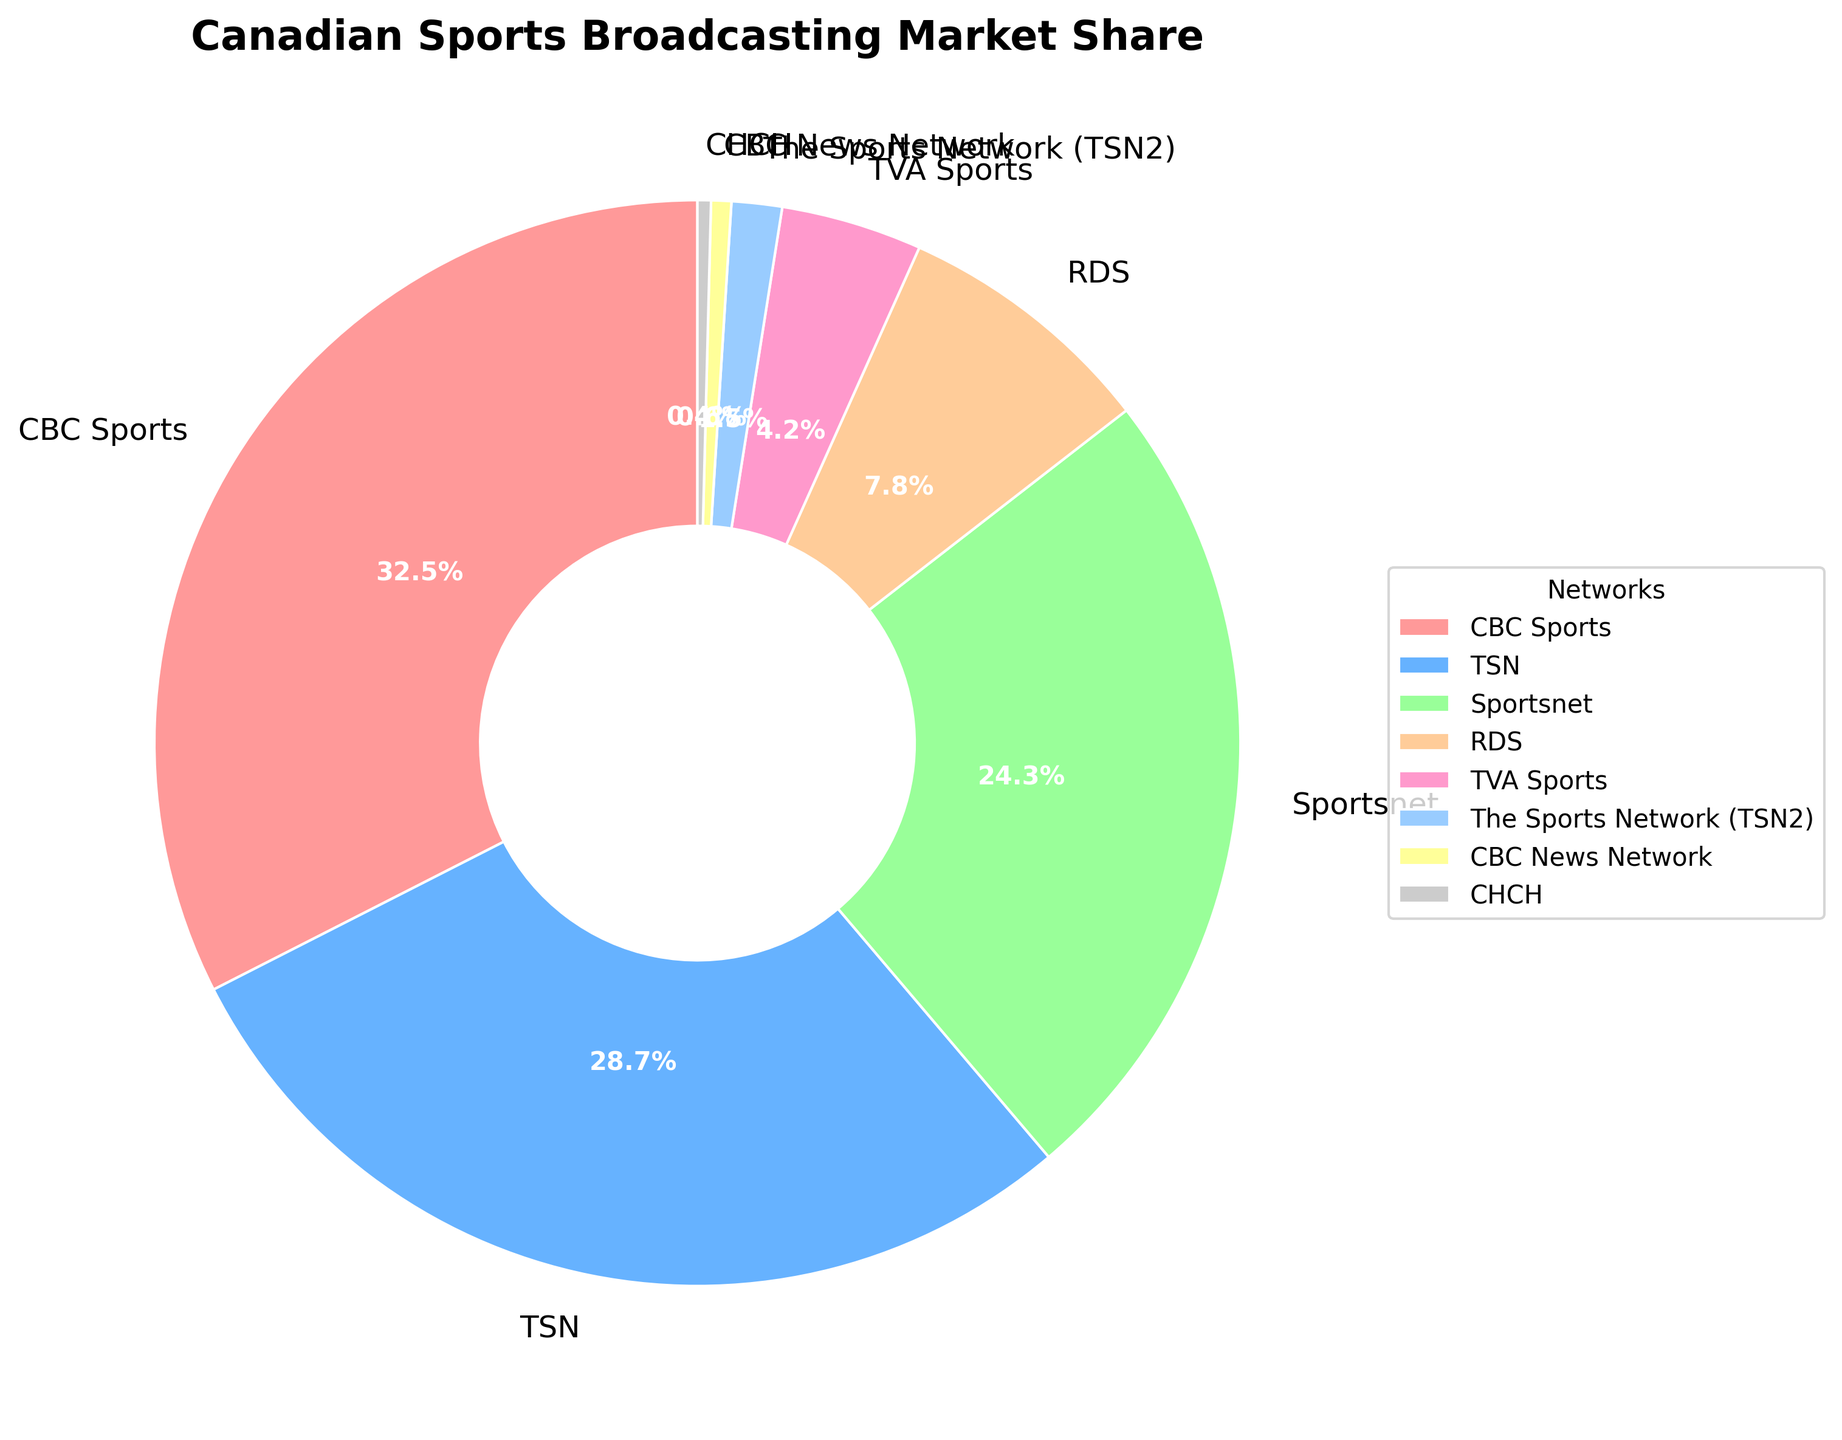What is the market share of CBC Sports? The market share is shown directly on the pie chart next to CBC Sports.
Answer: 32.5% Which network has a larger market share: TSN or Sportsnet? By comparing the percent labels on the chart, TSN's market share (28.7%) is larger than Sportsnet's (24.3%).
Answer: TSN What is the combined market share of TSN and The Sports Network (TSN2)? Add the market share of TSN (28.7%) and The Sports Network (TSN2) (1.5%) together: 28.7 + 1.5 = 30.2%.
Answer: 30.2% How much larger is CBC Sports' market share compared to RDS? Subtract the market share of RDS (7.8%) from CBC Sports' (32.5%): 32.5 - 7.8 = 24.7%.
Answer: 24.7% Which networks have a market share smaller than 5%? By examining the pie chart for percentages below 5%, the networks are TVA Sports (4.2%), The Sports Network (TSN2) (1.5%), CBC News Network (0.6%), and CHCH (0.4%).
Answer: TVA Sports, The Sports Network (TSN2), CBC News Network, CHCH What is the total market share of the networks not part of CBC, TSN, and Sportsnet? Add the market shares of RDS (7.8%), TVA Sports (4.2%), The Sports Network (TSN2) (1.5%), CBC News Network (0.6%), and CHCH (0.4%): 7.8 + 4.2 + 1.5 + 0.6 + 0.4 = 14.5%.
Answer: 14.5% Which network is represented by the red color in the pie chart? The largest wedge of the pie chart is colored red, and its label is CBC Sports.
Answer: CBC Sports What is the average market share of all the networks? Sum the market shares: 32.5 + 28.7 + 24.3 + 7.8 + 4.2 + 1.5 + 0.6 + 0.4 = 100%. Divide by the number of networks (8): 100 / 8 = 12.5%.
Answer: 12.5% If CBC Sports and Sportsnet were combined into one entity, what would their market share be? Add the market shares of CBC Sports (32.5%) and Sportsnet (24.3%): 32.5 + 24.3 = 56.8%.
Answer: 56.8% 